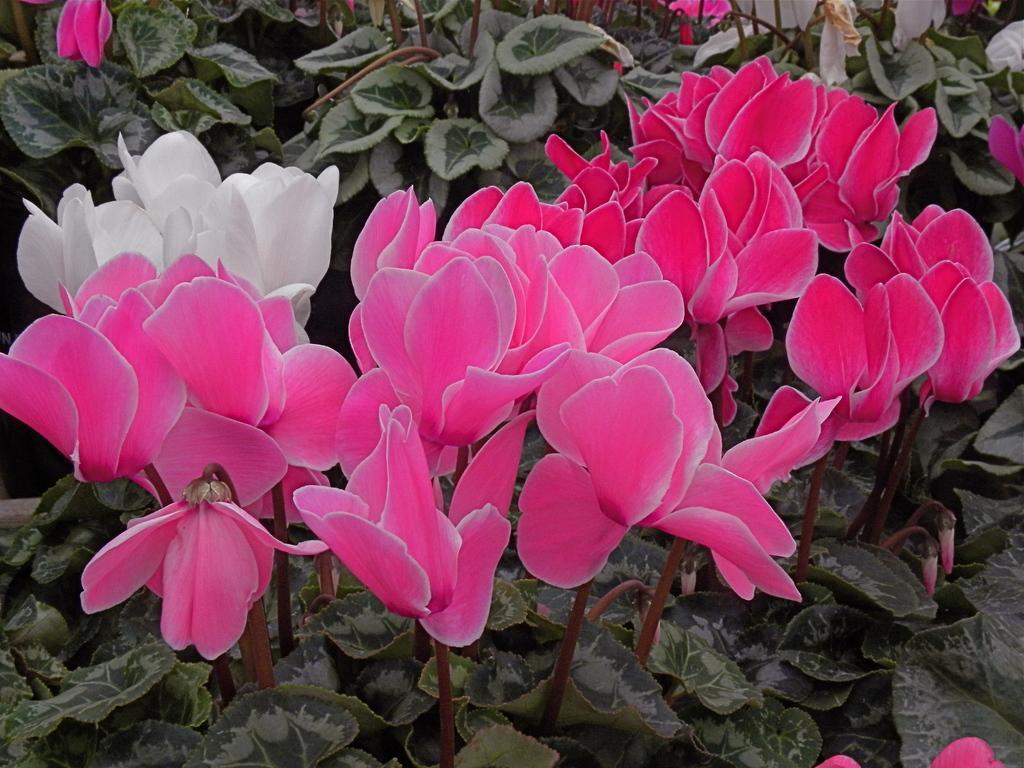Please provide a concise description of this image. This is an edited image. In the foreground of the picture there are lotus flowers. At the bottom there are leaves and buds. In the background there are plants and flowers. 